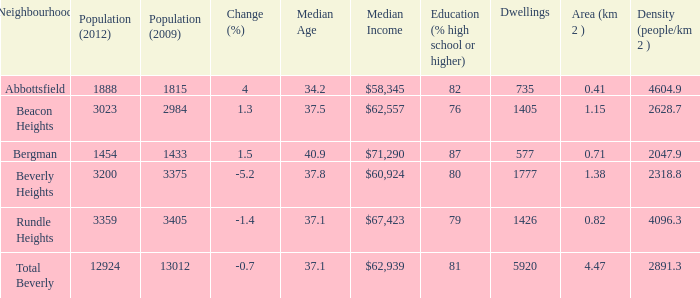Could you parse the entire table as a dict? {'header': ['Neighbourhood', 'Population (2012)', 'Population (2009)', 'Change (%)', 'Median Age', 'Median Income', 'Education (% high school or higher)', 'Dwellings', 'Area (km 2 )', 'Density (people/km 2 )'], 'rows': [['Abbottsfield', '1888', '1815', '4', '34.2', '$58,345', '82', '735', '0.41', '4604.9'], ['Beacon Heights', '3023', '2984', '1.3', '37.5', '$62,557', '76', '1405', '1.15', '2628.7'], ['Bergman', '1454', '1433', '1.5', '40.9', '$71,290', '87', '577', '0.71', '2047.9'], ['Beverly Heights', '3200', '3375', '-5.2', '37.8', '$60,924', '80', '1777', '1.38', '2318.8'], ['Rundle Heights', '3359', '3405', '-1.4', '37.1', '$67,423', '79', '1426', '0.82', '4096.3'], ['Total Beverly', '12924', '13012', '-0.7', '37.1', '$62,939', '81', '5920', '4.47', '2891.3']]} What is the density of an area that is 1.38km and has a population more than 12924? 0.0. 